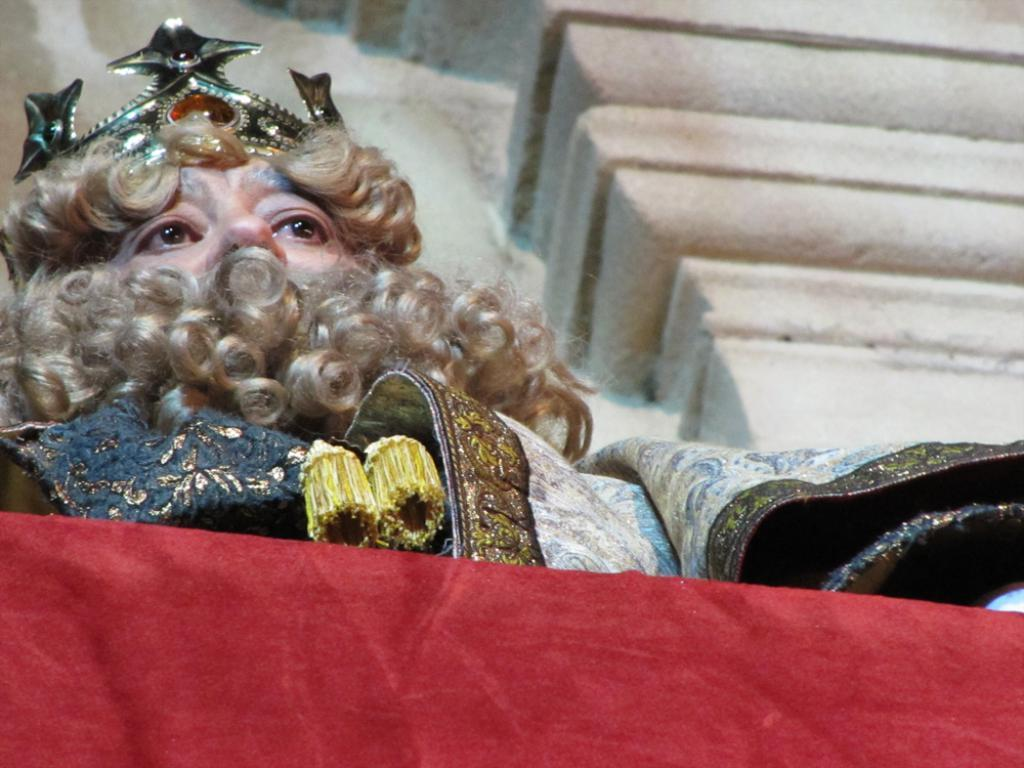Who or what is present in the image? There is a person in the image. What is the person wearing on their head? The person is wearing a crown on their head. Can you describe the object at the bottom of the image? There is a red color object at the bottom of the image. What type of plant is being tended to by the giants in the image? There are no giants or plants present in the image; it features a person wearing a crown. What kind of fowl can be seen flying in the background of the image? There are no fowl or background visible in the image; it only shows a person wearing a crown and a red color object at the bottom. 